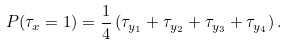Convert formula to latex. <formula><loc_0><loc_0><loc_500><loc_500>P ( \tau _ { x } = 1 ) = \frac { 1 } { 4 } \left ( \tau _ { y _ { 1 } } + \tau _ { y _ { 2 } } + \tau _ { y _ { 3 } } + \tau _ { y _ { 4 } } \right ) .</formula> 